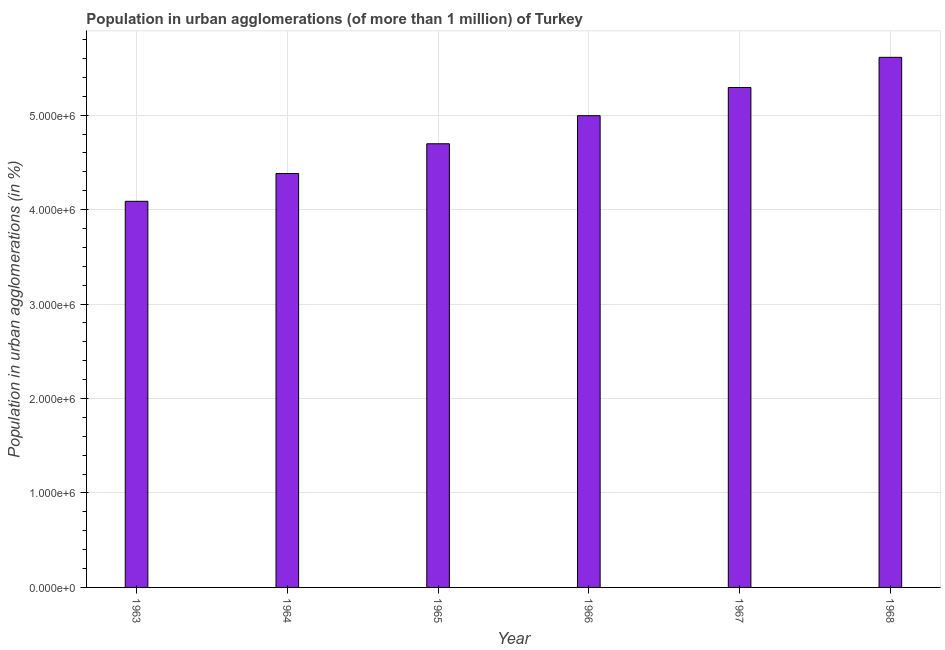Does the graph contain any zero values?
Ensure brevity in your answer.  No. What is the title of the graph?
Your answer should be very brief. Population in urban agglomerations (of more than 1 million) of Turkey. What is the label or title of the Y-axis?
Your response must be concise. Population in urban agglomerations (in %). What is the population in urban agglomerations in 1968?
Ensure brevity in your answer.  5.61e+06. Across all years, what is the maximum population in urban agglomerations?
Give a very brief answer. 5.61e+06. Across all years, what is the minimum population in urban agglomerations?
Give a very brief answer. 4.09e+06. In which year was the population in urban agglomerations maximum?
Your answer should be compact. 1968. In which year was the population in urban agglomerations minimum?
Provide a succinct answer. 1963. What is the sum of the population in urban agglomerations?
Offer a terse response. 2.91e+07. What is the difference between the population in urban agglomerations in 1966 and 1967?
Provide a succinct answer. -2.98e+05. What is the average population in urban agglomerations per year?
Offer a terse response. 4.84e+06. What is the median population in urban agglomerations?
Your answer should be compact. 4.85e+06. In how many years, is the population in urban agglomerations greater than 5000000 %?
Offer a very short reply. 2. What is the ratio of the population in urban agglomerations in 1963 to that in 1964?
Offer a terse response. 0.93. Is the population in urban agglomerations in 1964 less than that in 1967?
Offer a very short reply. Yes. What is the difference between the highest and the second highest population in urban agglomerations?
Give a very brief answer. 3.20e+05. Is the sum of the population in urban agglomerations in 1964 and 1966 greater than the maximum population in urban agglomerations across all years?
Provide a short and direct response. Yes. What is the difference between the highest and the lowest population in urban agglomerations?
Your answer should be compact. 1.52e+06. In how many years, is the population in urban agglomerations greater than the average population in urban agglomerations taken over all years?
Provide a short and direct response. 3. How many bars are there?
Offer a terse response. 6. How many years are there in the graph?
Ensure brevity in your answer.  6. What is the difference between two consecutive major ticks on the Y-axis?
Provide a succinct answer. 1.00e+06. Are the values on the major ticks of Y-axis written in scientific E-notation?
Your response must be concise. Yes. What is the Population in urban agglomerations (in %) of 1963?
Your response must be concise. 4.09e+06. What is the Population in urban agglomerations (in %) of 1964?
Offer a terse response. 4.38e+06. What is the Population in urban agglomerations (in %) of 1965?
Your answer should be compact. 4.70e+06. What is the Population in urban agglomerations (in %) of 1966?
Make the answer very short. 4.99e+06. What is the Population in urban agglomerations (in %) of 1967?
Offer a very short reply. 5.29e+06. What is the Population in urban agglomerations (in %) of 1968?
Your answer should be very brief. 5.61e+06. What is the difference between the Population in urban agglomerations (in %) in 1963 and 1964?
Your answer should be very brief. -2.94e+05. What is the difference between the Population in urban agglomerations (in %) in 1963 and 1965?
Provide a short and direct response. -6.09e+05. What is the difference between the Population in urban agglomerations (in %) in 1963 and 1966?
Ensure brevity in your answer.  -9.06e+05. What is the difference between the Population in urban agglomerations (in %) in 1963 and 1967?
Provide a short and direct response. -1.20e+06. What is the difference between the Population in urban agglomerations (in %) in 1963 and 1968?
Ensure brevity in your answer.  -1.52e+06. What is the difference between the Population in urban agglomerations (in %) in 1964 and 1965?
Keep it short and to the point. -3.15e+05. What is the difference between the Population in urban agglomerations (in %) in 1964 and 1966?
Provide a succinct answer. -6.12e+05. What is the difference between the Population in urban agglomerations (in %) in 1964 and 1967?
Your response must be concise. -9.11e+05. What is the difference between the Population in urban agglomerations (in %) in 1964 and 1968?
Your answer should be compact. -1.23e+06. What is the difference between the Population in urban agglomerations (in %) in 1965 and 1966?
Your answer should be very brief. -2.97e+05. What is the difference between the Population in urban agglomerations (in %) in 1965 and 1967?
Make the answer very short. -5.96e+05. What is the difference between the Population in urban agglomerations (in %) in 1965 and 1968?
Give a very brief answer. -9.15e+05. What is the difference between the Population in urban agglomerations (in %) in 1966 and 1967?
Keep it short and to the point. -2.98e+05. What is the difference between the Population in urban agglomerations (in %) in 1966 and 1968?
Make the answer very short. -6.18e+05. What is the difference between the Population in urban agglomerations (in %) in 1967 and 1968?
Your response must be concise. -3.20e+05. What is the ratio of the Population in urban agglomerations (in %) in 1963 to that in 1964?
Your response must be concise. 0.93. What is the ratio of the Population in urban agglomerations (in %) in 1963 to that in 1965?
Keep it short and to the point. 0.87. What is the ratio of the Population in urban agglomerations (in %) in 1963 to that in 1966?
Keep it short and to the point. 0.82. What is the ratio of the Population in urban agglomerations (in %) in 1963 to that in 1967?
Give a very brief answer. 0.77. What is the ratio of the Population in urban agglomerations (in %) in 1963 to that in 1968?
Give a very brief answer. 0.73. What is the ratio of the Population in urban agglomerations (in %) in 1964 to that in 1965?
Your response must be concise. 0.93. What is the ratio of the Population in urban agglomerations (in %) in 1964 to that in 1966?
Ensure brevity in your answer.  0.88. What is the ratio of the Population in urban agglomerations (in %) in 1964 to that in 1967?
Offer a very short reply. 0.83. What is the ratio of the Population in urban agglomerations (in %) in 1964 to that in 1968?
Provide a succinct answer. 0.78. What is the ratio of the Population in urban agglomerations (in %) in 1965 to that in 1966?
Provide a succinct answer. 0.94. What is the ratio of the Population in urban agglomerations (in %) in 1965 to that in 1967?
Your answer should be very brief. 0.89. What is the ratio of the Population in urban agglomerations (in %) in 1965 to that in 1968?
Make the answer very short. 0.84. What is the ratio of the Population in urban agglomerations (in %) in 1966 to that in 1967?
Provide a short and direct response. 0.94. What is the ratio of the Population in urban agglomerations (in %) in 1966 to that in 1968?
Offer a very short reply. 0.89. What is the ratio of the Population in urban agglomerations (in %) in 1967 to that in 1968?
Offer a very short reply. 0.94. 